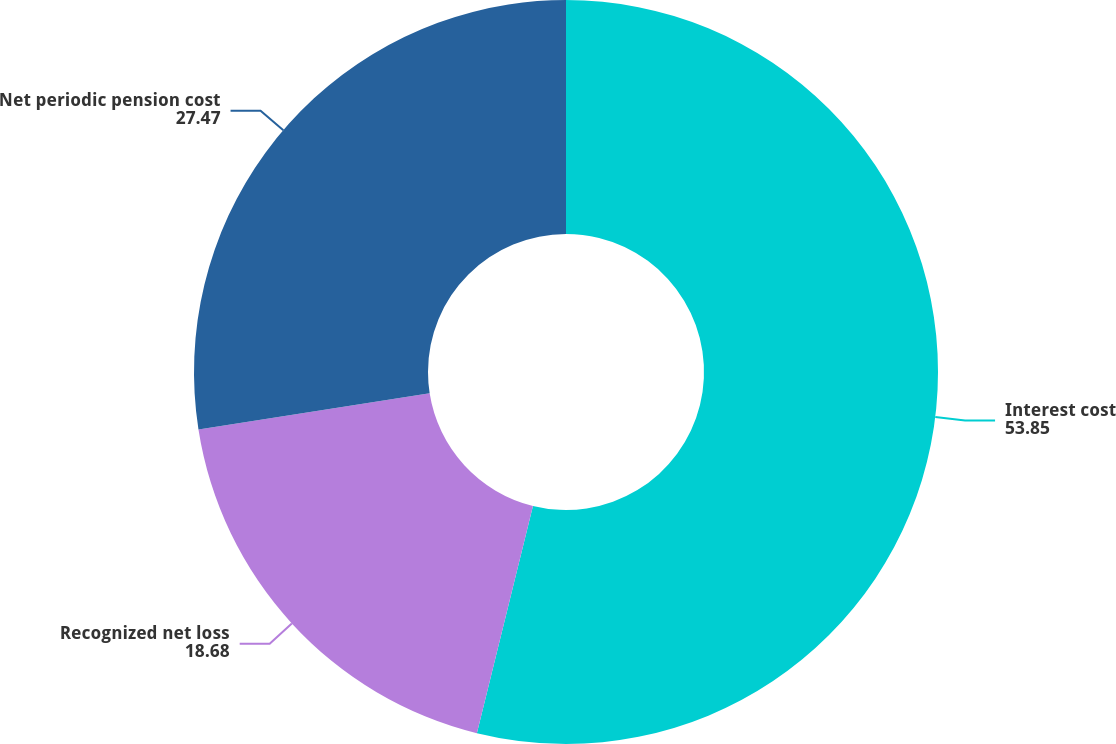Convert chart to OTSL. <chart><loc_0><loc_0><loc_500><loc_500><pie_chart><fcel>Interest cost<fcel>Recognized net loss<fcel>Net periodic pension cost<nl><fcel>53.85%<fcel>18.68%<fcel>27.47%<nl></chart> 